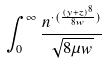<formula> <loc_0><loc_0><loc_500><loc_500>\int _ { 0 } ^ { \infty } \frac { n ^ { \cdot ( \frac { ( y + z ) ^ { 8 } } { 8 w } ) } } { \sqrt { 8 \mu w } }</formula> 